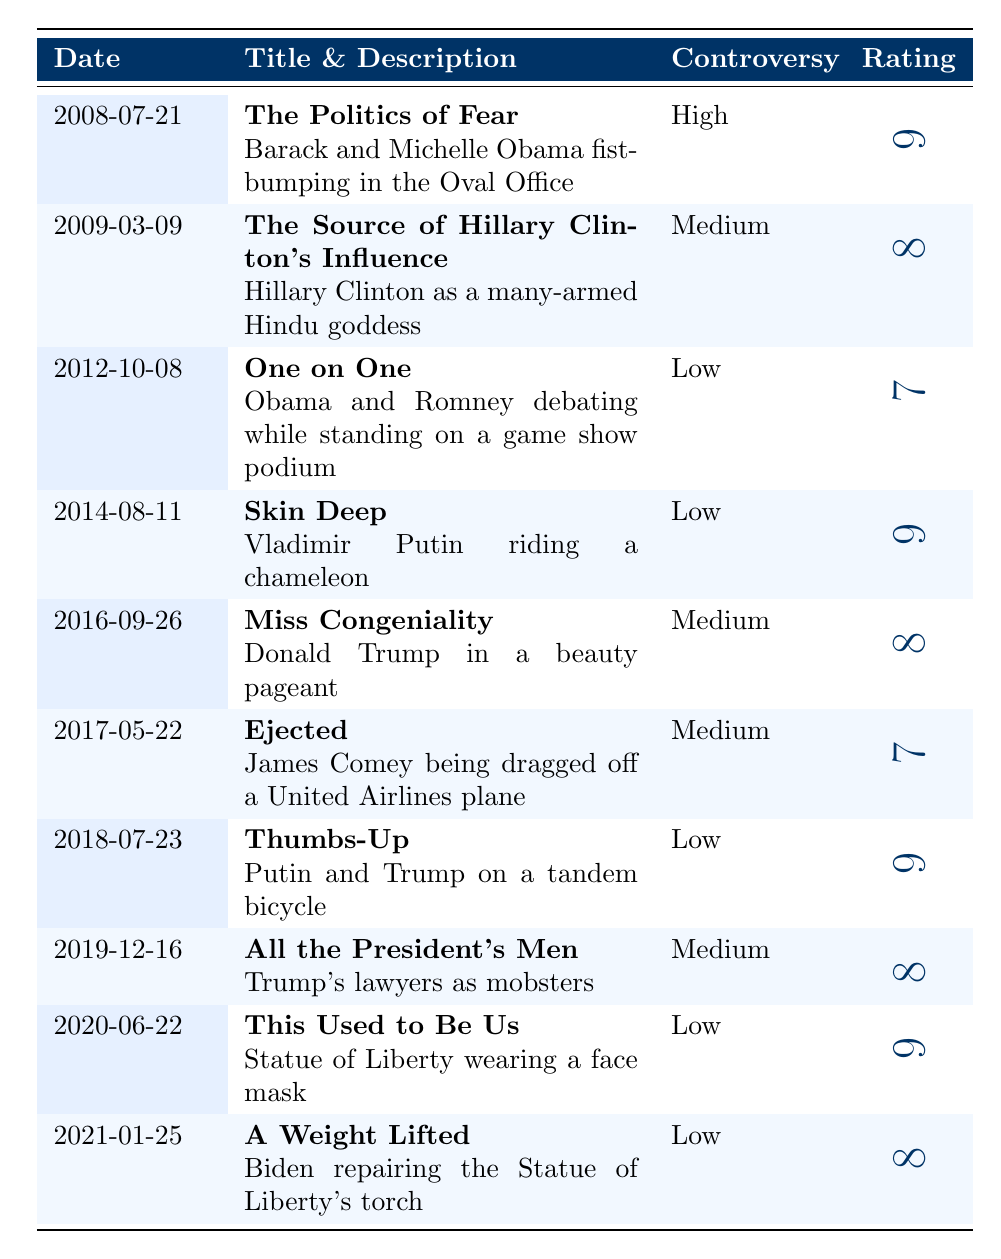What is the title of the cover released on July 21, 2008? The title of the cover is under the "Title" column for the date July 21, 2008, which is "The Politics of Fear".
Answer: The Politics of Fear Which cover has the highest personal rating? Looking at the "Personal Rating" column, the highest value is 9. Checking the corresponding titles, "The Politics of Fear", "Skin Deep", "Thumbs-Up", and "This Used to Be Us" all share this rating.
Answer: The Politics of Fear, Skin Deep, Thumbs-Up, This Used to Be Us What was the controversy level for "Miss Congeniality"? Referring to the "Controversy" column for the row corresponding to "Miss Congeniality", it is listed as "Medium".
Answer: Medium How many covers are rated higher than 8? The covers with personal ratings higher than 8 are "The Politics of Fear", "Skin Deep", "Thumbs-Up", and "This Used to Be Us". Counting these gives a total of 4 covers.
Answer: 4 Is there a cover that depicts a political figure as a god or goddess? The description for "The Source of Hillary Clinton's Influence" states that it displays "Hillary Clinton as a many-armed Hindu goddess", which confirms that there is such a cover.
Answer: Yes What is the average rating for covers released after 2015? The covers after 2015 are: "Ejected" (7), "Thumbs-Up" (9), "All the President's Men" (8), "This Used to Be Us" (9), and "A Weight Lifted" (8). Summing these ratings gives 7 + 9 + 8 + 9 + 8 = 41. There are 5 covers, so the average is 41/5 = 8.2.
Answer: 8.2 Which cover features the Statue of Liberty, and what is its personal rating? The cover titled "This Used to Be Us" depicts the Statue of Liberty wearing a face mask and has a personal rating of 9.
Answer: This Used to Be Us, 9 How many covers depicted Vladimir Putin? The covers that depicted Vladimir Putin are "Skin Deep" (where he is riding a chameleon) and "Thumbs-Up" (where he is on a tandem bicycle with Trump). This totals 2 covers.
Answer: 2 What controversy level does the cover "All the President's Men" have? In the "Controversy" column for "All the President's Men", it is listed as "Medium".
Answer: Medium Among the covers, who is depicted alongside Trump in "Thumbs-Up"? According to the description for "Thumbs-Up", Vladimir Putin is depicted alongside Trump on a tandem bicycle.
Answer: Vladimir Putin 